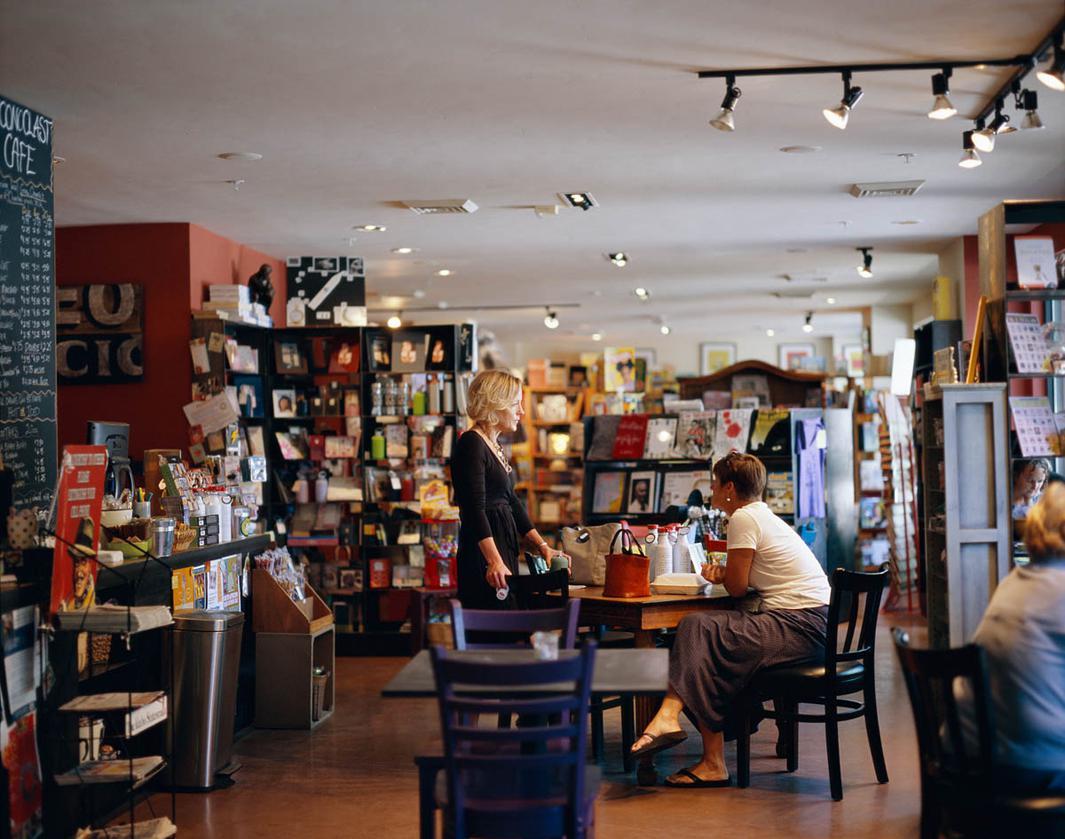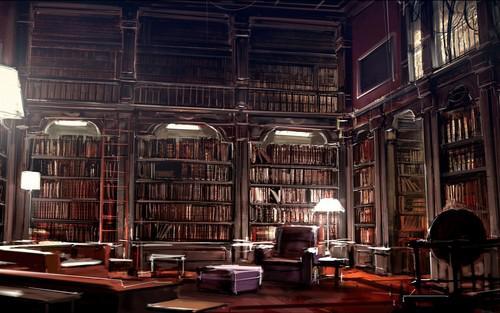The first image is the image on the left, the second image is the image on the right. Assess this claim about the two images: "In at least one image there at least two bookshelves with one window in between them.". Correct or not? Answer yes or no. No. The first image is the image on the left, the second image is the image on the right. For the images displayed, is the sentence "An interior features bookshelves under at least one arch shape at the back, and upholstered furniture in front." factually correct? Answer yes or no. Yes. 